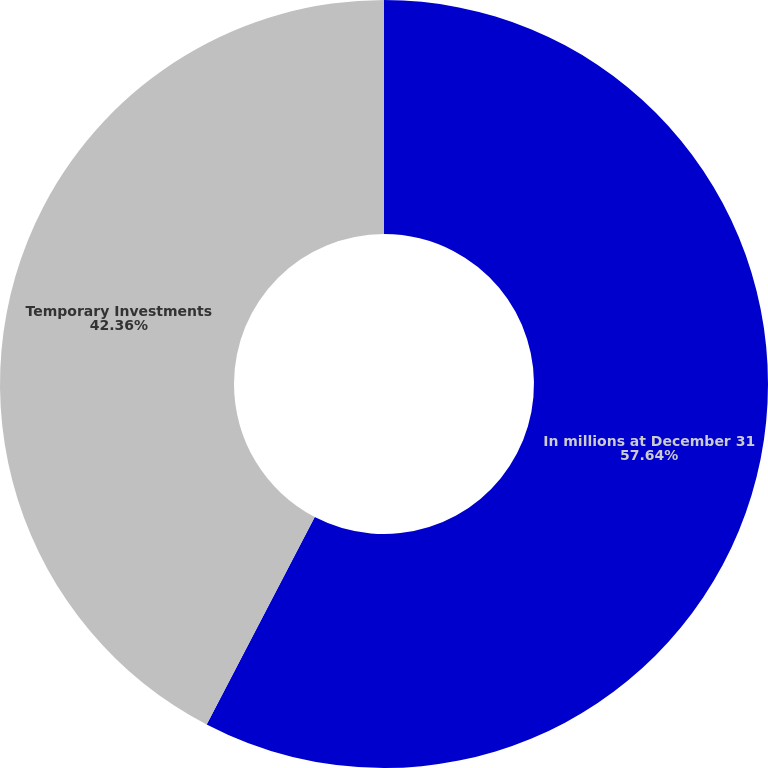Convert chart to OTSL. <chart><loc_0><loc_0><loc_500><loc_500><pie_chart><fcel>In millions at December 31<fcel>Temporary Investments<nl><fcel>57.64%<fcel>42.36%<nl></chart> 